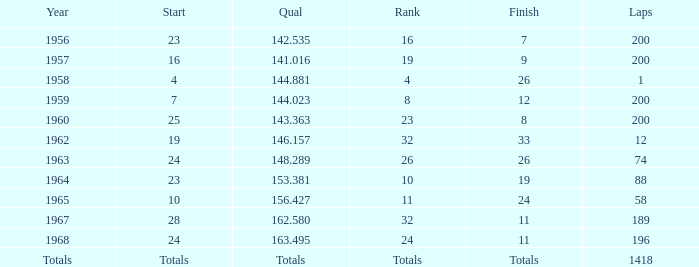What is the largest number of laps that have a final sum of 8? 200.0. 